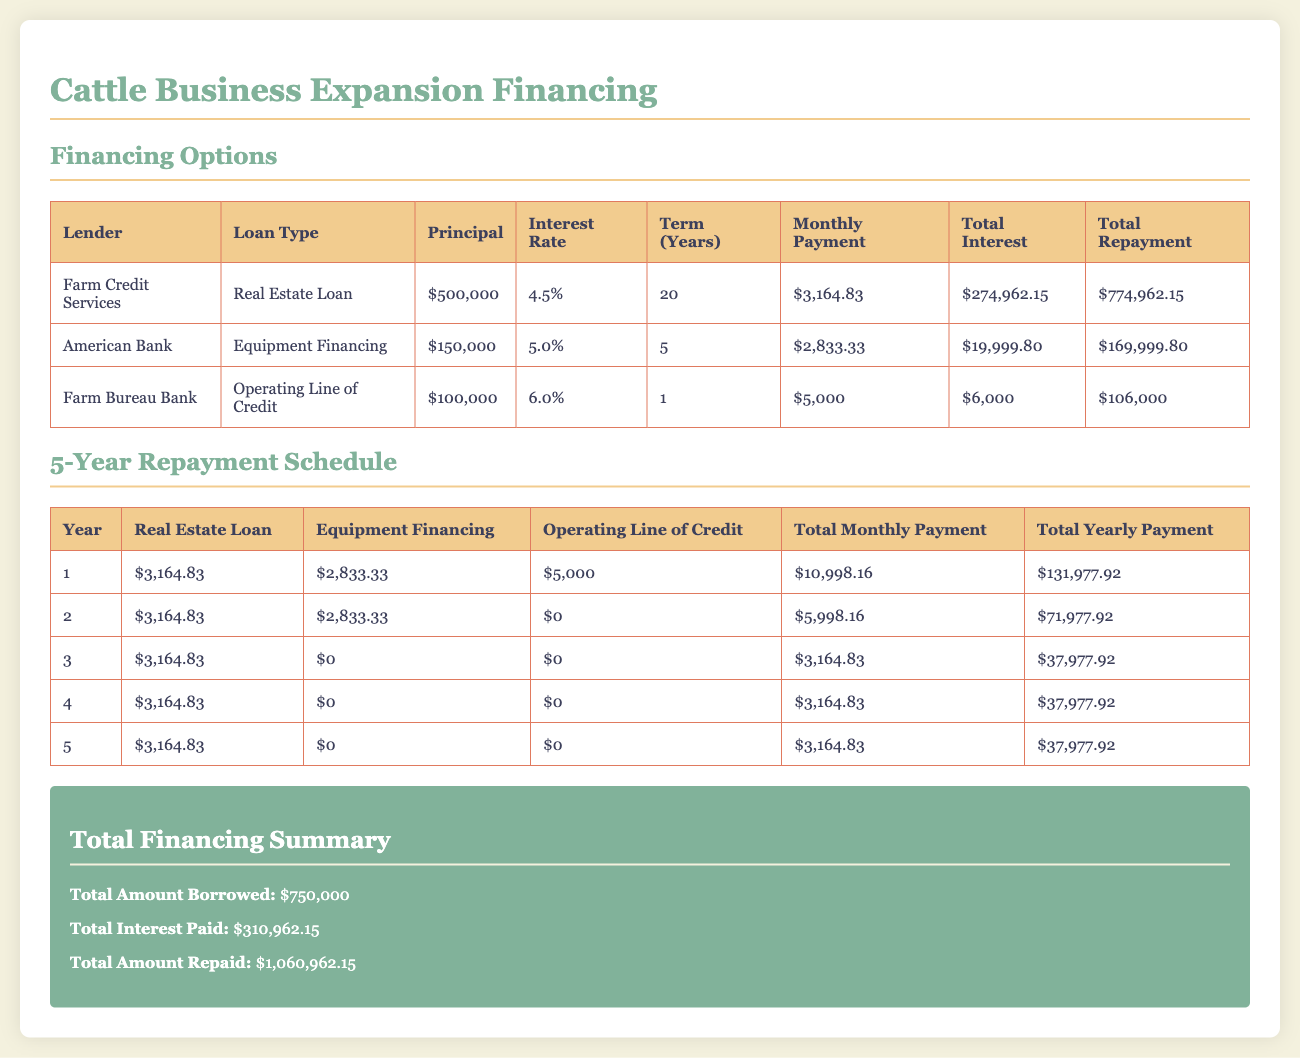What is the total amount borrowed? The total amount borrowed is stated in the summary section of the document.
Answer: $750,000 What is the interest rate for the Equipment Financing? The interest rate for Equipment Financing is found in the table listing financing options.
Answer: 5.0% What is the monthly payment for the Real Estate Loan? The monthly payment for the Real Estate Loan is provided in the financing options table.
Answer: $3,164.83 How much total interest will be paid for the Operating Line of Credit? The total interest paid is indicated in the financing options table under the Operating Line of Credit.
Answer: $6,000 What is the total yearly payment in the first year? The total yearly payment for the first year can be calculated using the first row of the repayment schedule.
Answer: $131,977.92 Which lender offers the Operating Line of Credit? The lender for the Operating Line of Credit is specifically listed in the financing options table.
Answer: Farm Bureau Bank What is the total interest paid over five years? The total interest paid is shown in the summary section of the document.
Answer: $310,962.15 What is the repayment term for the Equipment Financing? The repayment term for the Equipment Financing is indicated in the financing options table.
Answer: 5 years 